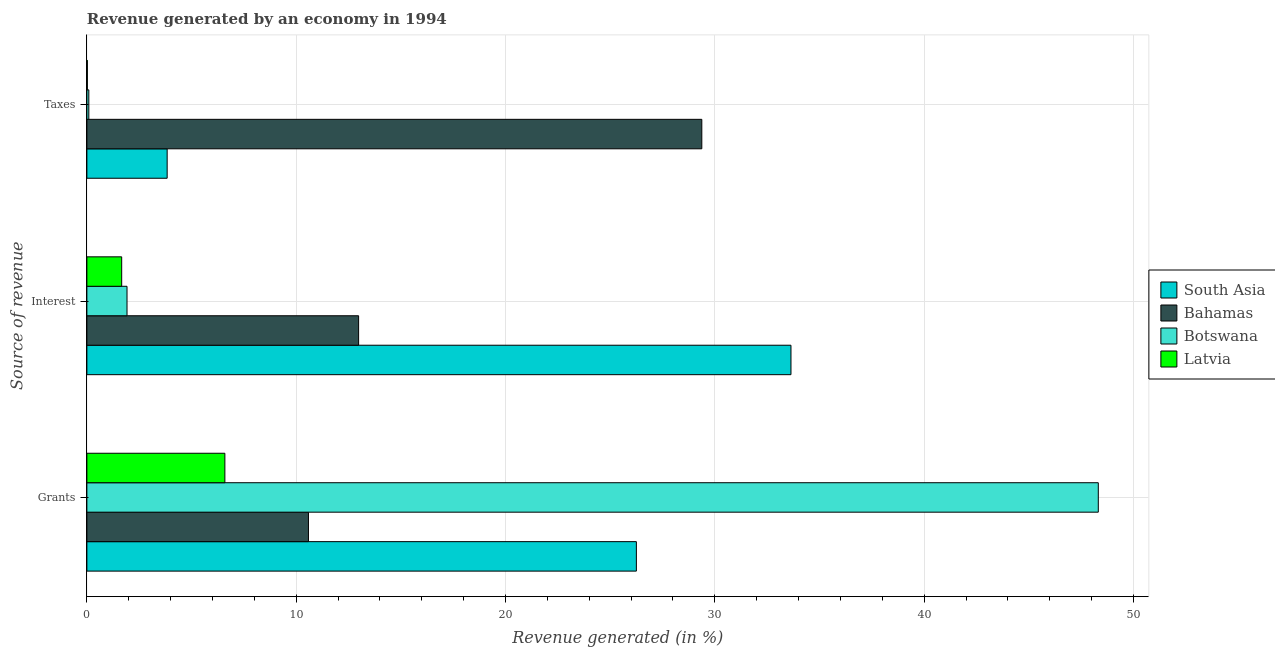Are the number of bars per tick equal to the number of legend labels?
Keep it short and to the point. Yes. Are the number of bars on each tick of the Y-axis equal?
Your response must be concise. Yes. How many bars are there on the 3rd tick from the bottom?
Keep it short and to the point. 4. What is the label of the 1st group of bars from the top?
Ensure brevity in your answer.  Taxes. What is the percentage of revenue generated by grants in Bahamas?
Keep it short and to the point. 10.59. Across all countries, what is the maximum percentage of revenue generated by grants?
Provide a short and direct response. 48.32. Across all countries, what is the minimum percentage of revenue generated by grants?
Give a very brief answer. 6.59. In which country was the percentage of revenue generated by grants minimum?
Your answer should be compact. Latvia. What is the total percentage of revenue generated by grants in the graph?
Your answer should be very brief. 91.75. What is the difference between the percentage of revenue generated by interest in Botswana and that in Latvia?
Provide a short and direct response. 0.25. What is the difference between the percentage of revenue generated by interest in Bahamas and the percentage of revenue generated by taxes in South Asia?
Give a very brief answer. 9.15. What is the average percentage of revenue generated by taxes per country?
Provide a succinct answer. 8.33. What is the difference between the percentage of revenue generated by grants and percentage of revenue generated by interest in Botswana?
Provide a succinct answer. 46.4. What is the ratio of the percentage of revenue generated by grants in Latvia to that in Botswana?
Ensure brevity in your answer.  0.14. Is the percentage of revenue generated by interest in Botswana less than that in South Asia?
Your answer should be very brief. Yes. What is the difference between the highest and the second highest percentage of revenue generated by taxes?
Your response must be concise. 25.54. What is the difference between the highest and the lowest percentage of revenue generated by interest?
Keep it short and to the point. 31.97. Is it the case that in every country, the sum of the percentage of revenue generated by grants and percentage of revenue generated by interest is greater than the percentage of revenue generated by taxes?
Provide a short and direct response. No. How many bars are there?
Your response must be concise. 12. How many countries are there in the graph?
Make the answer very short. 4. How many legend labels are there?
Ensure brevity in your answer.  4. How are the legend labels stacked?
Provide a short and direct response. Vertical. What is the title of the graph?
Offer a very short reply. Revenue generated by an economy in 1994. What is the label or title of the X-axis?
Provide a short and direct response. Revenue generated (in %). What is the label or title of the Y-axis?
Provide a short and direct response. Source of revenue. What is the Revenue generated (in %) of South Asia in Grants?
Give a very brief answer. 26.25. What is the Revenue generated (in %) in Bahamas in Grants?
Provide a short and direct response. 10.59. What is the Revenue generated (in %) in Botswana in Grants?
Make the answer very short. 48.32. What is the Revenue generated (in %) of Latvia in Grants?
Keep it short and to the point. 6.59. What is the Revenue generated (in %) of South Asia in Interest?
Provide a succinct answer. 33.64. What is the Revenue generated (in %) of Bahamas in Interest?
Make the answer very short. 12.98. What is the Revenue generated (in %) in Botswana in Interest?
Your answer should be very brief. 1.92. What is the Revenue generated (in %) of Latvia in Interest?
Ensure brevity in your answer.  1.66. What is the Revenue generated (in %) in South Asia in Taxes?
Provide a succinct answer. 3.84. What is the Revenue generated (in %) in Bahamas in Taxes?
Give a very brief answer. 29.38. What is the Revenue generated (in %) of Botswana in Taxes?
Your response must be concise. 0.09. What is the Revenue generated (in %) of Latvia in Taxes?
Your answer should be very brief. 0.02. Across all Source of revenue, what is the maximum Revenue generated (in %) of South Asia?
Your answer should be compact. 33.64. Across all Source of revenue, what is the maximum Revenue generated (in %) in Bahamas?
Ensure brevity in your answer.  29.38. Across all Source of revenue, what is the maximum Revenue generated (in %) in Botswana?
Give a very brief answer. 48.32. Across all Source of revenue, what is the maximum Revenue generated (in %) in Latvia?
Offer a very short reply. 6.59. Across all Source of revenue, what is the minimum Revenue generated (in %) in South Asia?
Provide a succinct answer. 3.84. Across all Source of revenue, what is the minimum Revenue generated (in %) in Bahamas?
Provide a succinct answer. 10.59. Across all Source of revenue, what is the minimum Revenue generated (in %) of Botswana?
Your answer should be compact. 0.09. Across all Source of revenue, what is the minimum Revenue generated (in %) of Latvia?
Keep it short and to the point. 0.02. What is the total Revenue generated (in %) of South Asia in the graph?
Your response must be concise. 63.72. What is the total Revenue generated (in %) in Bahamas in the graph?
Your response must be concise. 52.95. What is the total Revenue generated (in %) in Botswana in the graph?
Keep it short and to the point. 50.33. What is the total Revenue generated (in %) of Latvia in the graph?
Offer a very short reply. 8.28. What is the difference between the Revenue generated (in %) of South Asia in Grants and that in Interest?
Provide a short and direct response. -7.39. What is the difference between the Revenue generated (in %) of Bahamas in Grants and that in Interest?
Your answer should be very brief. -2.4. What is the difference between the Revenue generated (in %) in Botswana in Grants and that in Interest?
Give a very brief answer. 46.4. What is the difference between the Revenue generated (in %) in Latvia in Grants and that in Interest?
Your answer should be compact. 4.93. What is the difference between the Revenue generated (in %) of South Asia in Grants and that in Taxes?
Ensure brevity in your answer.  22.42. What is the difference between the Revenue generated (in %) of Bahamas in Grants and that in Taxes?
Your response must be concise. -18.79. What is the difference between the Revenue generated (in %) in Botswana in Grants and that in Taxes?
Ensure brevity in your answer.  48.23. What is the difference between the Revenue generated (in %) in Latvia in Grants and that in Taxes?
Provide a short and direct response. 6.57. What is the difference between the Revenue generated (in %) of South Asia in Interest and that in Taxes?
Provide a short and direct response. 29.8. What is the difference between the Revenue generated (in %) in Bahamas in Interest and that in Taxes?
Your answer should be very brief. -16.4. What is the difference between the Revenue generated (in %) in Botswana in Interest and that in Taxes?
Your answer should be compact. 1.82. What is the difference between the Revenue generated (in %) of Latvia in Interest and that in Taxes?
Ensure brevity in your answer.  1.64. What is the difference between the Revenue generated (in %) in South Asia in Grants and the Revenue generated (in %) in Bahamas in Interest?
Your answer should be very brief. 13.27. What is the difference between the Revenue generated (in %) in South Asia in Grants and the Revenue generated (in %) in Botswana in Interest?
Provide a short and direct response. 24.33. What is the difference between the Revenue generated (in %) of South Asia in Grants and the Revenue generated (in %) of Latvia in Interest?
Provide a short and direct response. 24.59. What is the difference between the Revenue generated (in %) of Bahamas in Grants and the Revenue generated (in %) of Botswana in Interest?
Offer a terse response. 8.67. What is the difference between the Revenue generated (in %) in Bahamas in Grants and the Revenue generated (in %) in Latvia in Interest?
Offer a terse response. 8.92. What is the difference between the Revenue generated (in %) in Botswana in Grants and the Revenue generated (in %) in Latvia in Interest?
Provide a succinct answer. 46.66. What is the difference between the Revenue generated (in %) in South Asia in Grants and the Revenue generated (in %) in Bahamas in Taxes?
Provide a succinct answer. -3.13. What is the difference between the Revenue generated (in %) of South Asia in Grants and the Revenue generated (in %) of Botswana in Taxes?
Offer a terse response. 26.16. What is the difference between the Revenue generated (in %) in South Asia in Grants and the Revenue generated (in %) in Latvia in Taxes?
Keep it short and to the point. 26.23. What is the difference between the Revenue generated (in %) in Bahamas in Grants and the Revenue generated (in %) in Botswana in Taxes?
Give a very brief answer. 10.49. What is the difference between the Revenue generated (in %) in Bahamas in Grants and the Revenue generated (in %) in Latvia in Taxes?
Give a very brief answer. 10.56. What is the difference between the Revenue generated (in %) in Botswana in Grants and the Revenue generated (in %) in Latvia in Taxes?
Provide a short and direct response. 48.3. What is the difference between the Revenue generated (in %) of South Asia in Interest and the Revenue generated (in %) of Bahamas in Taxes?
Give a very brief answer. 4.26. What is the difference between the Revenue generated (in %) of South Asia in Interest and the Revenue generated (in %) of Botswana in Taxes?
Offer a very short reply. 33.54. What is the difference between the Revenue generated (in %) in South Asia in Interest and the Revenue generated (in %) in Latvia in Taxes?
Give a very brief answer. 33.61. What is the difference between the Revenue generated (in %) in Bahamas in Interest and the Revenue generated (in %) in Botswana in Taxes?
Provide a succinct answer. 12.89. What is the difference between the Revenue generated (in %) of Bahamas in Interest and the Revenue generated (in %) of Latvia in Taxes?
Offer a very short reply. 12.96. What is the difference between the Revenue generated (in %) in Botswana in Interest and the Revenue generated (in %) in Latvia in Taxes?
Offer a very short reply. 1.89. What is the average Revenue generated (in %) of South Asia per Source of revenue?
Offer a terse response. 21.24. What is the average Revenue generated (in %) in Bahamas per Source of revenue?
Make the answer very short. 17.65. What is the average Revenue generated (in %) of Botswana per Source of revenue?
Make the answer very short. 16.78. What is the average Revenue generated (in %) in Latvia per Source of revenue?
Offer a terse response. 2.76. What is the difference between the Revenue generated (in %) of South Asia and Revenue generated (in %) of Bahamas in Grants?
Your answer should be very brief. 15.67. What is the difference between the Revenue generated (in %) in South Asia and Revenue generated (in %) in Botswana in Grants?
Provide a short and direct response. -22.07. What is the difference between the Revenue generated (in %) of South Asia and Revenue generated (in %) of Latvia in Grants?
Keep it short and to the point. 19.66. What is the difference between the Revenue generated (in %) of Bahamas and Revenue generated (in %) of Botswana in Grants?
Make the answer very short. -37.73. What is the difference between the Revenue generated (in %) in Bahamas and Revenue generated (in %) in Latvia in Grants?
Ensure brevity in your answer.  3.99. What is the difference between the Revenue generated (in %) in Botswana and Revenue generated (in %) in Latvia in Grants?
Offer a terse response. 41.73. What is the difference between the Revenue generated (in %) in South Asia and Revenue generated (in %) in Bahamas in Interest?
Provide a succinct answer. 20.66. What is the difference between the Revenue generated (in %) of South Asia and Revenue generated (in %) of Botswana in Interest?
Keep it short and to the point. 31.72. What is the difference between the Revenue generated (in %) in South Asia and Revenue generated (in %) in Latvia in Interest?
Keep it short and to the point. 31.97. What is the difference between the Revenue generated (in %) of Bahamas and Revenue generated (in %) of Botswana in Interest?
Offer a terse response. 11.06. What is the difference between the Revenue generated (in %) in Bahamas and Revenue generated (in %) in Latvia in Interest?
Make the answer very short. 11.32. What is the difference between the Revenue generated (in %) in Botswana and Revenue generated (in %) in Latvia in Interest?
Your response must be concise. 0.25. What is the difference between the Revenue generated (in %) of South Asia and Revenue generated (in %) of Bahamas in Taxes?
Your answer should be compact. -25.54. What is the difference between the Revenue generated (in %) of South Asia and Revenue generated (in %) of Botswana in Taxes?
Offer a terse response. 3.74. What is the difference between the Revenue generated (in %) of South Asia and Revenue generated (in %) of Latvia in Taxes?
Keep it short and to the point. 3.81. What is the difference between the Revenue generated (in %) in Bahamas and Revenue generated (in %) in Botswana in Taxes?
Keep it short and to the point. 29.28. What is the difference between the Revenue generated (in %) of Bahamas and Revenue generated (in %) of Latvia in Taxes?
Your answer should be very brief. 29.36. What is the difference between the Revenue generated (in %) of Botswana and Revenue generated (in %) of Latvia in Taxes?
Offer a very short reply. 0.07. What is the ratio of the Revenue generated (in %) of South Asia in Grants to that in Interest?
Ensure brevity in your answer.  0.78. What is the ratio of the Revenue generated (in %) in Bahamas in Grants to that in Interest?
Provide a succinct answer. 0.82. What is the ratio of the Revenue generated (in %) of Botswana in Grants to that in Interest?
Provide a short and direct response. 25.2. What is the ratio of the Revenue generated (in %) in Latvia in Grants to that in Interest?
Provide a short and direct response. 3.96. What is the ratio of the Revenue generated (in %) in South Asia in Grants to that in Taxes?
Your answer should be very brief. 6.84. What is the ratio of the Revenue generated (in %) of Bahamas in Grants to that in Taxes?
Your answer should be very brief. 0.36. What is the ratio of the Revenue generated (in %) in Botswana in Grants to that in Taxes?
Ensure brevity in your answer.  519.34. What is the ratio of the Revenue generated (in %) of Latvia in Grants to that in Taxes?
Provide a succinct answer. 288.08. What is the ratio of the Revenue generated (in %) of South Asia in Interest to that in Taxes?
Your answer should be very brief. 8.77. What is the ratio of the Revenue generated (in %) in Bahamas in Interest to that in Taxes?
Offer a terse response. 0.44. What is the ratio of the Revenue generated (in %) in Botswana in Interest to that in Taxes?
Give a very brief answer. 20.61. What is the ratio of the Revenue generated (in %) of Latvia in Interest to that in Taxes?
Ensure brevity in your answer.  72.67. What is the difference between the highest and the second highest Revenue generated (in %) of South Asia?
Offer a very short reply. 7.39. What is the difference between the highest and the second highest Revenue generated (in %) of Bahamas?
Make the answer very short. 16.4. What is the difference between the highest and the second highest Revenue generated (in %) of Botswana?
Give a very brief answer. 46.4. What is the difference between the highest and the second highest Revenue generated (in %) in Latvia?
Offer a very short reply. 4.93. What is the difference between the highest and the lowest Revenue generated (in %) in South Asia?
Keep it short and to the point. 29.8. What is the difference between the highest and the lowest Revenue generated (in %) in Bahamas?
Keep it short and to the point. 18.79. What is the difference between the highest and the lowest Revenue generated (in %) in Botswana?
Provide a short and direct response. 48.23. What is the difference between the highest and the lowest Revenue generated (in %) of Latvia?
Your response must be concise. 6.57. 